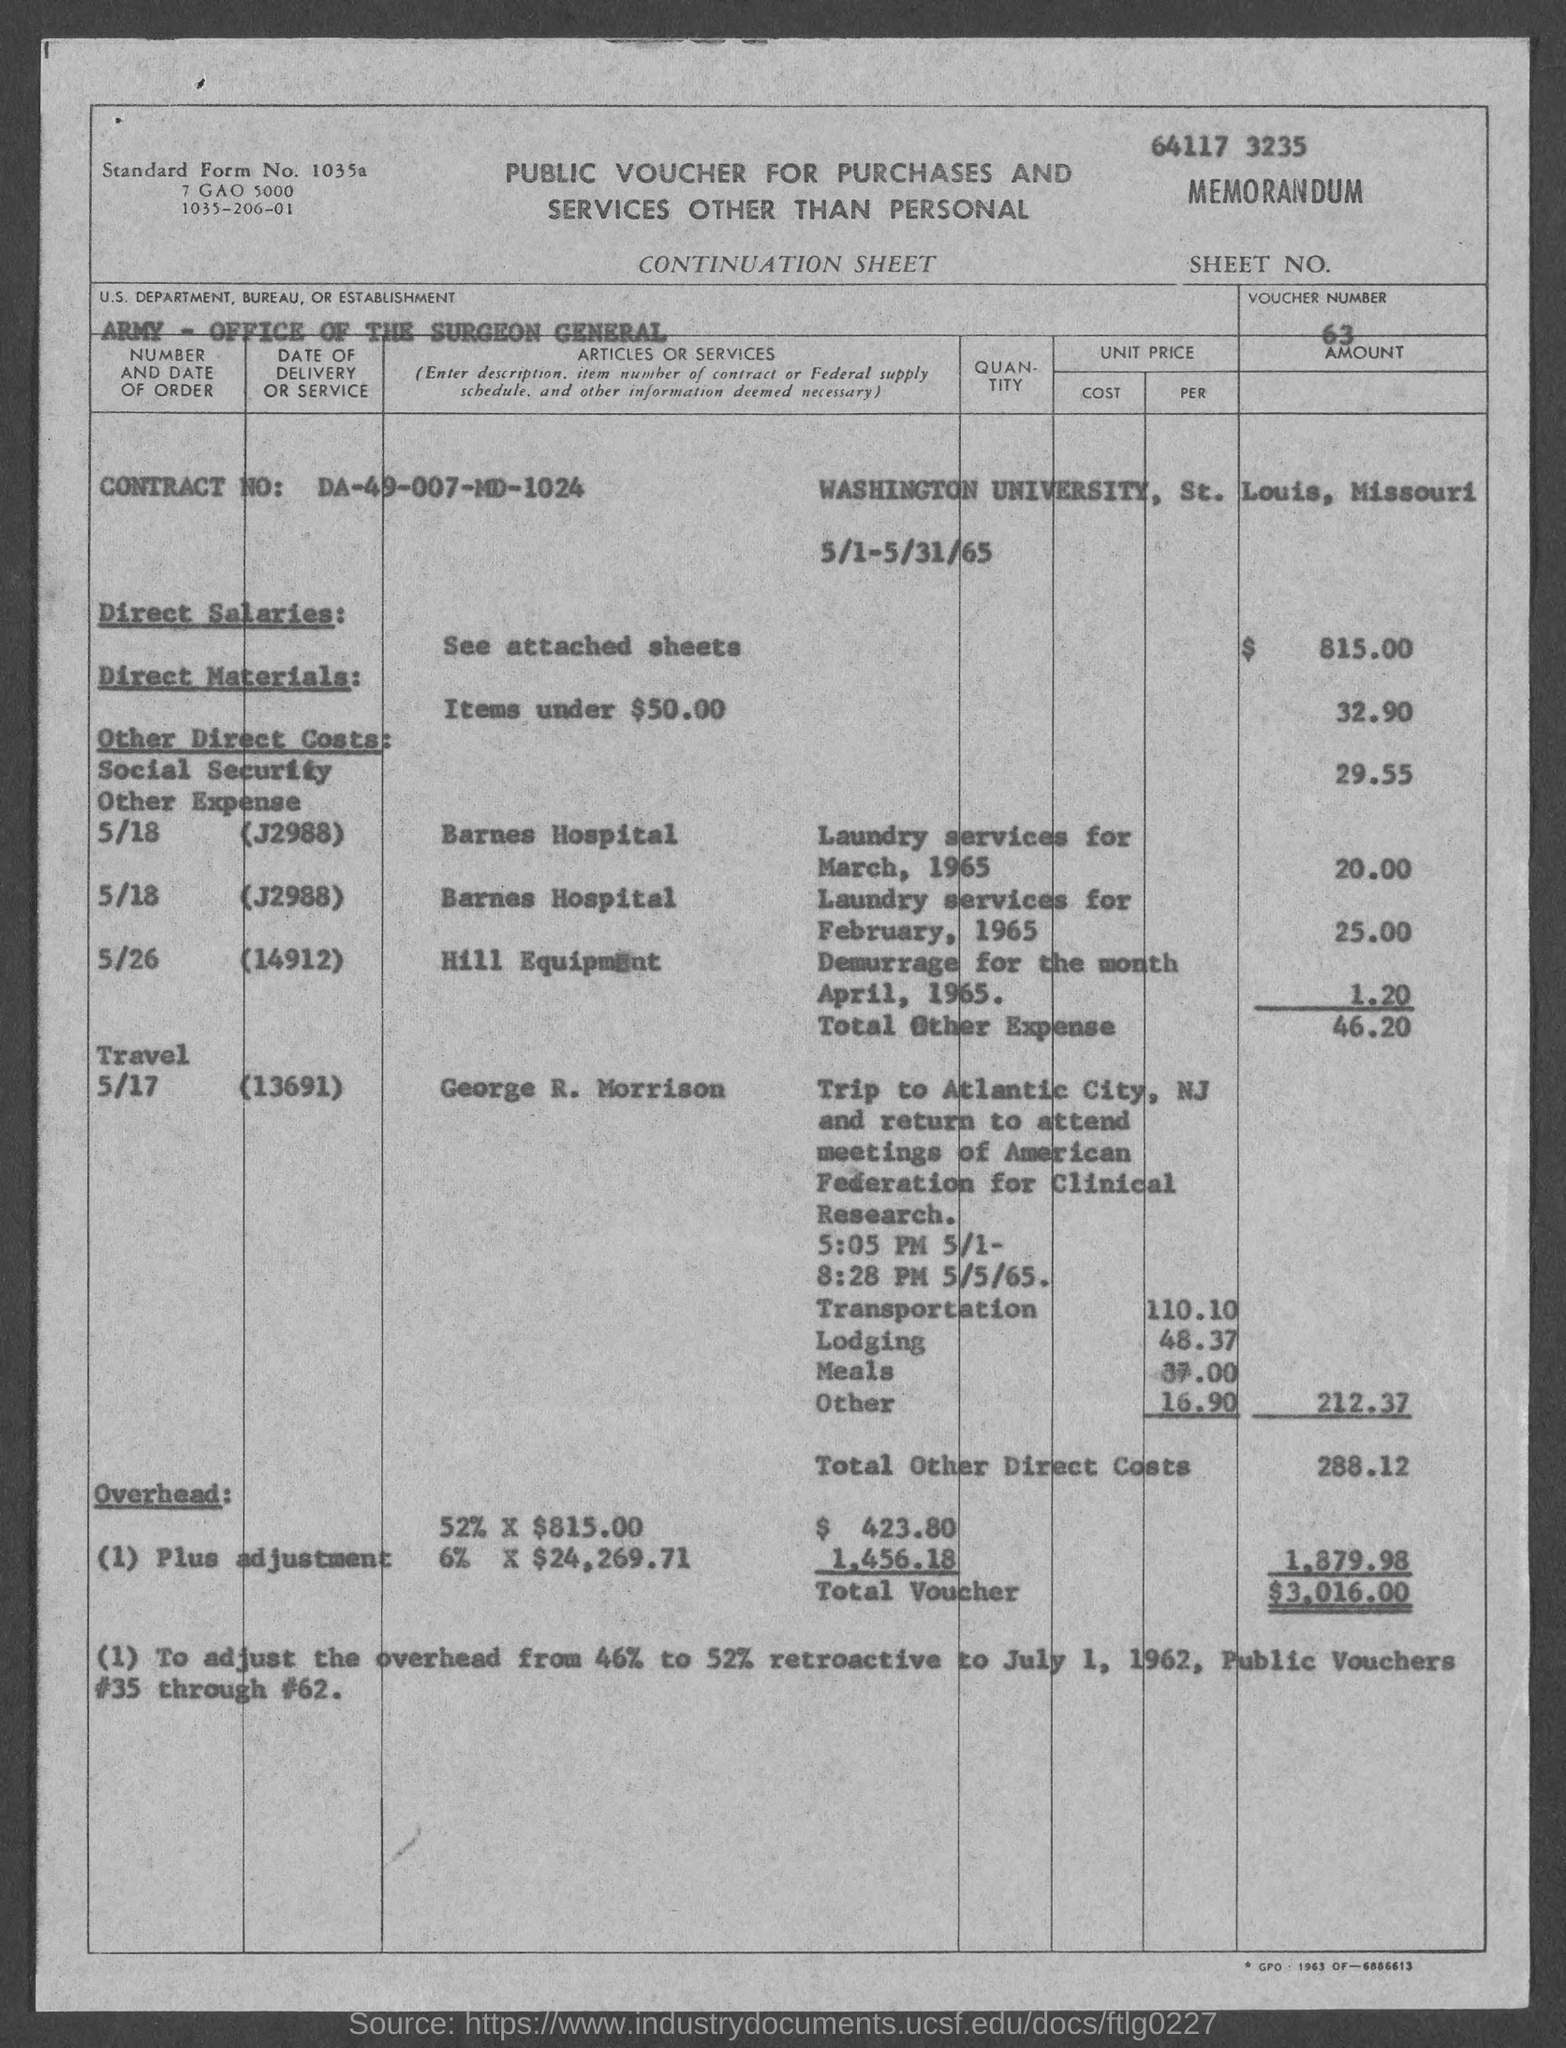What is the voucher number ?
Give a very brief answer. 63. What is the contract no.?
Offer a terse response. DA-49-007-MD-1024. What is the us. department, bureau, or establishment in voucher?
Your answer should be compact. Army- Office of the Surgeon General. What is the total voucher amount ?
Offer a very short reply. $3,016.00. 